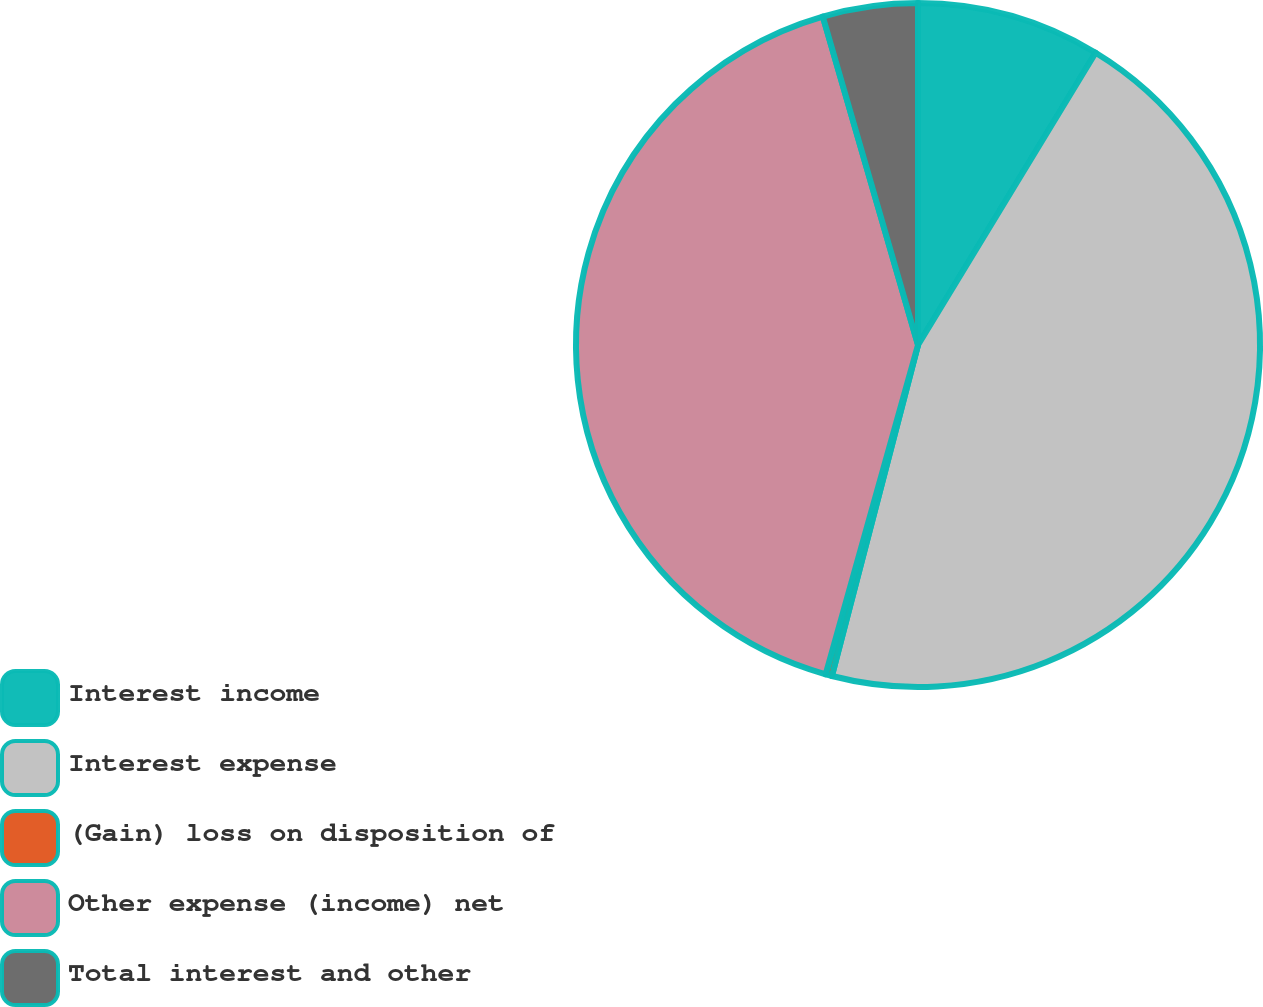Convert chart to OTSL. <chart><loc_0><loc_0><loc_500><loc_500><pie_chart><fcel>Interest income<fcel>Interest expense<fcel>(Gain) loss on disposition of<fcel>Other expense (income) net<fcel>Total interest and other<nl><fcel>8.69%<fcel>45.36%<fcel>0.3%<fcel>41.16%<fcel>4.49%<nl></chart> 